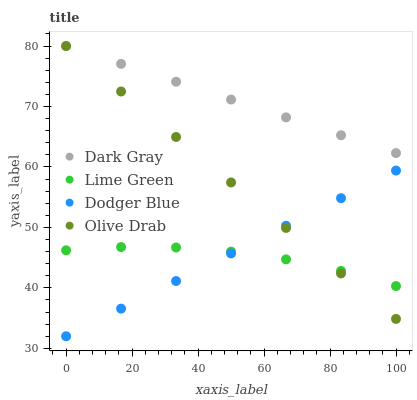Does Lime Green have the minimum area under the curve?
Answer yes or no. Yes. Does Dark Gray have the maximum area under the curve?
Answer yes or no. Yes. Does Dodger Blue have the minimum area under the curve?
Answer yes or no. No. Does Dodger Blue have the maximum area under the curve?
Answer yes or no. No. Is Dark Gray the smoothest?
Answer yes or no. Yes. Is Lime Green the roughest?
Answer yes or no. Yes. Is Dodger Blue the smoothest?
Answer yes or no. No. Is Dodger Blue the roughest?
Answer yes or no. No. Does Dodger Blue have the lowest value?
Answer yes or no. Yes. Does Lime Green have the lowest value?
Answer yes or no. No. Does Olive Drab have the highest value?
Answer yes or no. Yes. Does Dodger Blue have the highest value?
Answer yes or no. No. Is Dodger Blue less than Dark Gray?
Answer yes or no. Yes. Is Dark Gray greater than Dodger Blue?
Answer yes or no. Yes. Does Olive Drab intersect Dark Gray?
Answer yes or no. Yes. Is Olive Drab less than Dark Gray?
Answer yes or no. No. Is Olive Drab greater than Dark Gray?
Answer yes or no. No. Does Dodger Blue intersect Dark Gray?
Answer yes or no. No. 